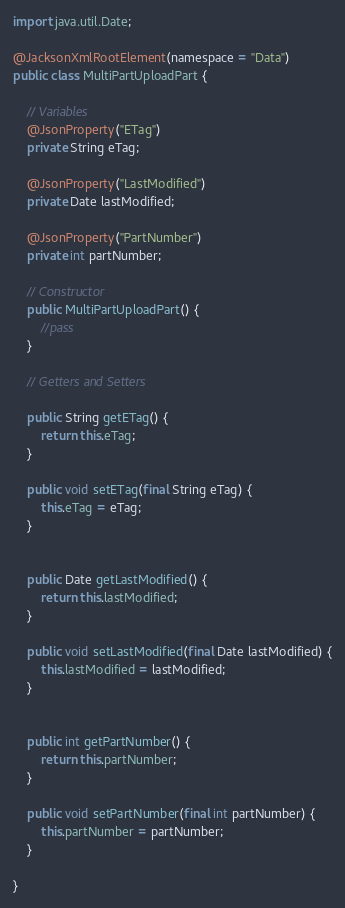<code> <loc_0><loc_0><loc_500><loc_500><_Java_>import java.util.Date;

@JacksonXmlRootElement(namespace = "Data")
public class MultiPartUploadPart {

    // Variables
    @JsonProperty("ETag")
    private String eTag;

    @JsonProperty("LastModified")
    private Date lastModified;

    @JsonProperty("PartNumber")
    private int partNumber;

    // Constructor
    public MultiPartUploadPart() {
        //pass
    }

    // Getters and Setters
    
    public String getETag() {
        return this.eTag;
    }

    public void setETag(final String eTag) {
        this.eTag = eTag;
    }


    public Date getLastModified() {
        return this.lastModified;
    }

    public void setLastModified(final Date lastModified) {
        this.lastModified = lastModified;
    }


    public int getPartNumber() {
        return this.partNumber;
    }

    public void setPartNumber(final int partNumber) {
        this.partNumber = partNumber;
    }

}</code> 